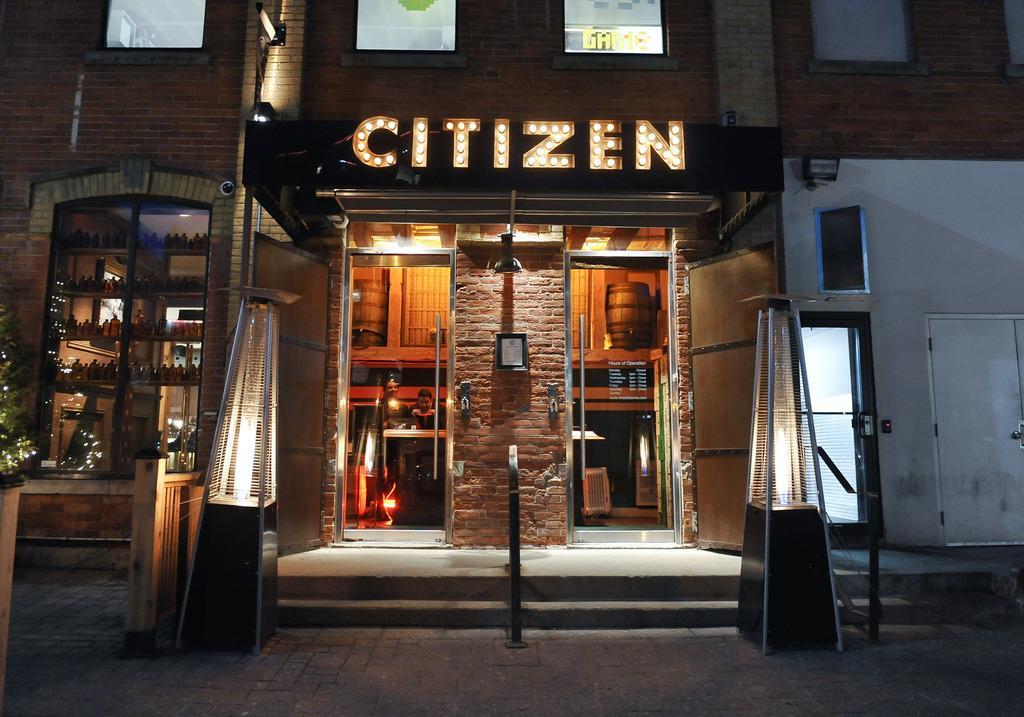Describe this image in one or two sentences. In the center of the image we can see a building with two doors. Inside the building we can see two persons. At the top of the image we can see windows of the building. At the bottom of the image there is a ground. 